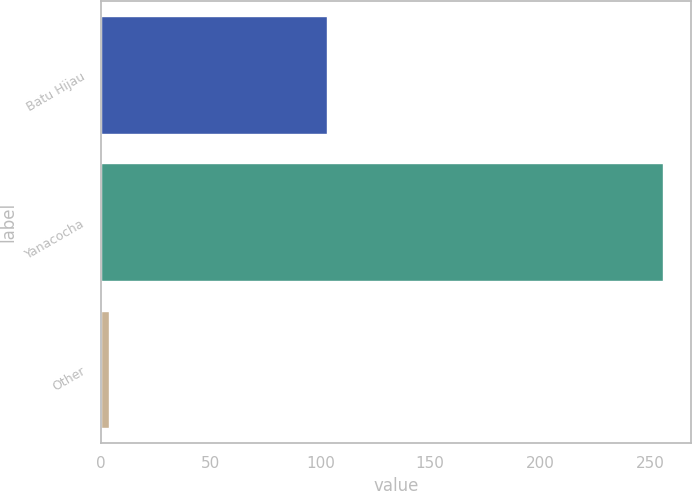<chart> <loc_0><loc_0><loc_500><loc_500><bar_chart><fcel>Batu Hijau<fcel>Yanacocha<fcel>Other<nl><fcel>103<fcel>256<fcel>4<nl></chart> 